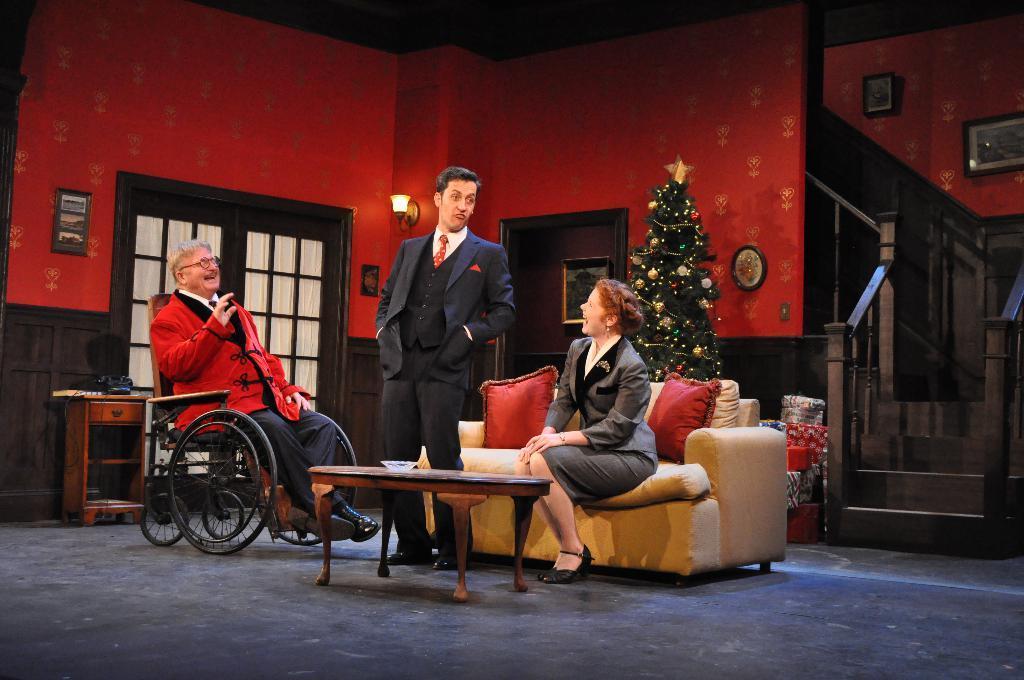In one or two sentences, can you explain what this image depicts? This image is taken in a room. A person is standing is wearing suit , tie and shoe. A woman is sitting on sofa having two red colour cushions. At the left side there is a person sitting on the wheelchair, before them there is a table. At the back side of them there is a christmas tree, beside there are few gifts. At the right side there is a staircase and two picture frames attached to the wall. There is a door beside christmas tree. At the left side there is a door, beside there is a cabin. 